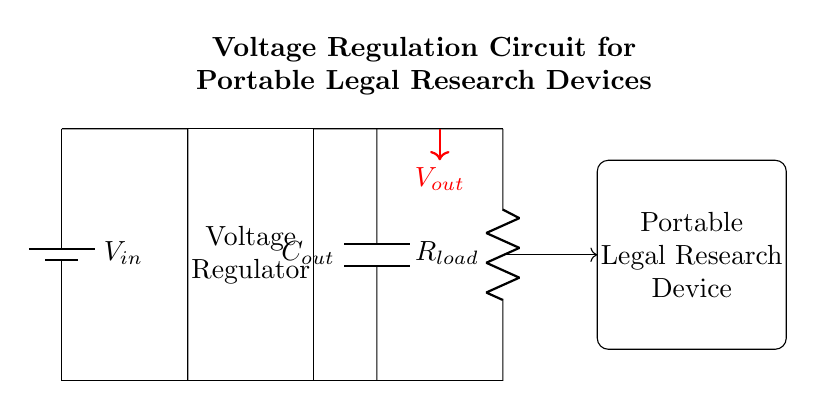What type of voltage regulator is used in this circuit? The circuit diagram does not specify the type of voltage regulator, but it generally implies the use of a linear or switching regulator. The design shows a simple block for the voltage regulator without any specific details.
Answer: Voltage regulator What does C_out represent in the circuit? C_out is labeled in the circuit with a capacitor symbol. Its purpose is typically to smooth the output voltage by filtering out any voltage ripples, providing stable voltage to the load.
Answer: Output capacitor What is the main function of the voltage regulator in this circuit? The primary function of the voltage regulator is to maintain a constant output voltage (V_out) despite variations in the input voltage (V_in) and load conditions. This stability is essential for sensitive devices like the portable legal research device shown.
Answer: Maintain constant voltage What is the load connected to the output of the voltage regulator? The circuit indicates that R_load is connected as the load. This resistor represents the device's power consumption, modeling the actual current demand from the voltage regulator.
Answer: Resistor How does the voltage regulation affect portable device operation? A stable output voltage from the regulator ensures that the portable device operates correctly without fluctuations that could lead to malfunction or data corruption, particularly crucial in legal research and document management tasks.
Answer: Ensures correct operation What is the input source voltage referred to in the circuit? The diagram labels the input source voltage as V_in, which typically denotes the battery voltage supplied to the circuit. This is essential for powering the voltage regulator and the connected load.
Answer: V_in 